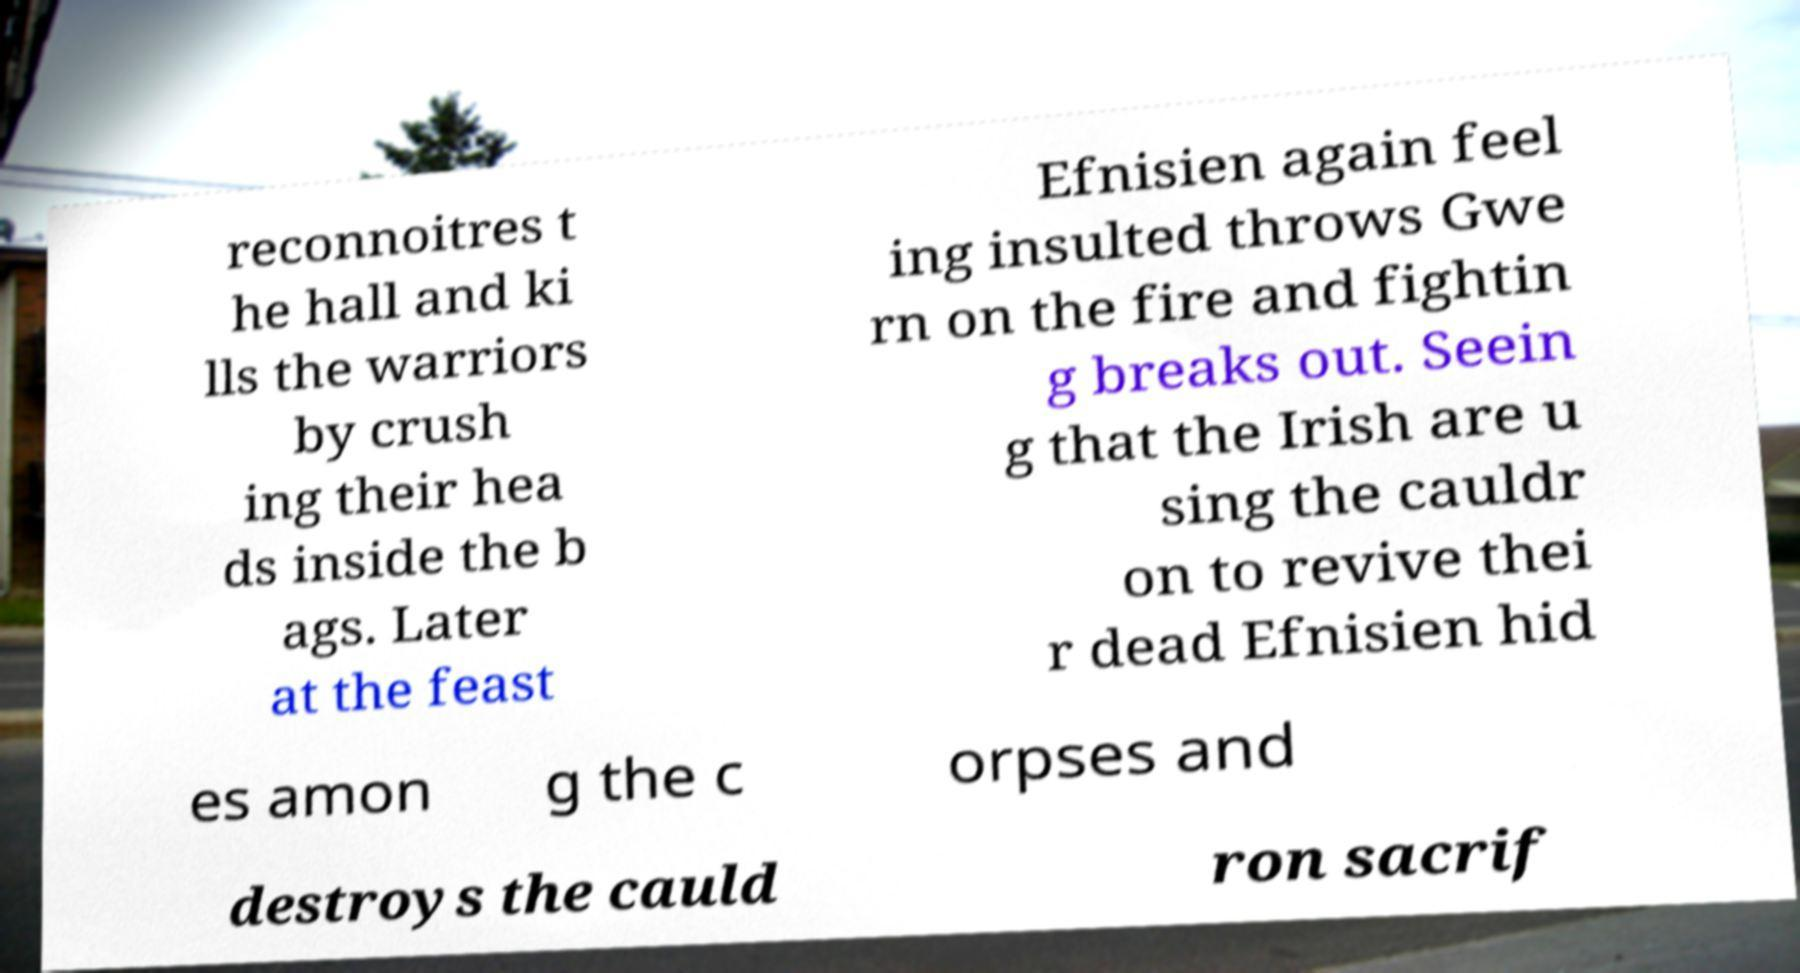There's text embedded in this image that I need extracted. Can you transcribe it verbatim? reconnoitres t he hall and ki lls the warriors by crush ing their hea ds inside the b ags. Later at the feast Efnisien again feel ing insulted throws Gwe rn on the fire and fightin g breaks out. Seein g that the Irish are u sing the cauldr on to revive thei r dead Efnisien hid es amon g the c orpses and destroys the cauld ron sacrif 